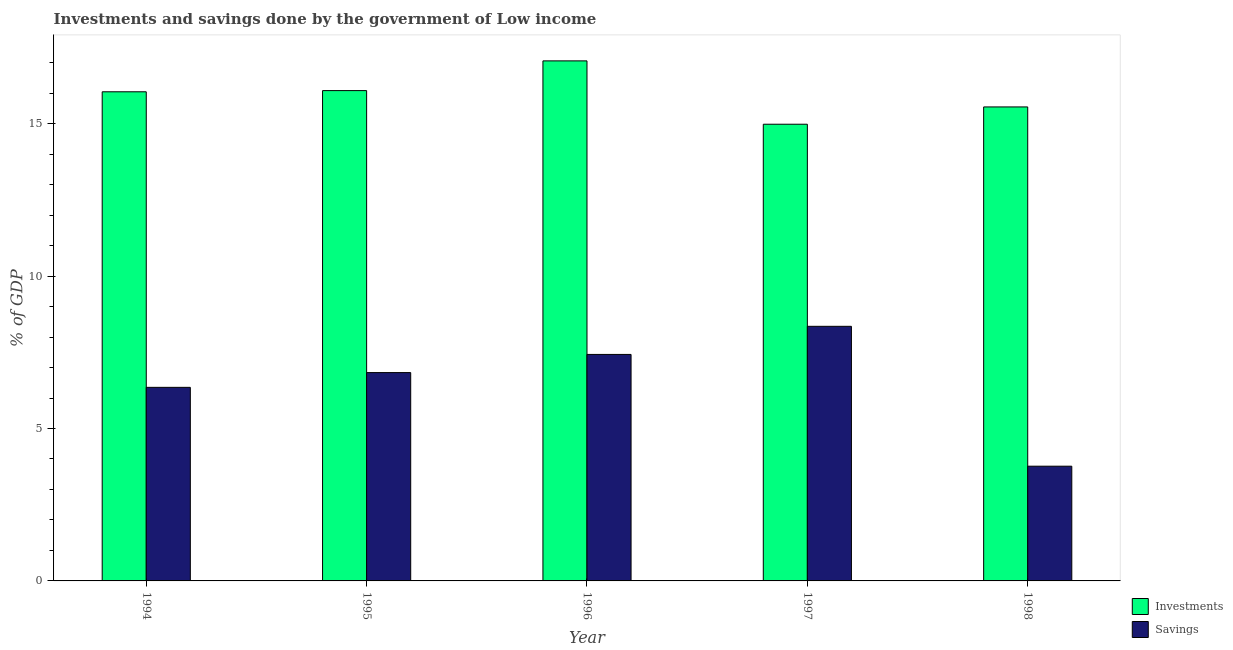How many different coloured bars are there?
Offer a very short reply. 2. How many groups of bars are there?
Offer a terse response. 5. Are the number of bars on each tick of the X-axis equal?
Your response must be concise. Yes. How many bars are there on the 3rd tick from the left?
Provide a succinct answer. 2. What is the label of the 3rd group of bars from the left?
Make the answer very short. 1996. In how many cases, is the number of bars for a given year not equal to the number of legend labels?
Keep it short and to the point. 0. What is the savings of government in 1996?
Ensure brevity in your answer.  7.43. Across all years, what is the maximum savings of government?
Provide a short and direct response. 8.35. Across all years, what is the minimum investments of government?
Your answer should be compact. 14.98. In which year was the savings of government minimum?
Your response must be concise. 1998. What is the total savings of government in the graph?
Make the answer very short. 32.73. What is the difference between the investments of government in 1997 and that in 1998?
Make the answer very short. -0.57. What is the difference between the savings of government in 1995 and the investments of government in 1996?
Provide a short and direct response. -0.6. What is the average investments of government per year?
Your answer should be compact. 15.94. In how many years, is the investments of government greater than 12 %?
Ensure brevity in your answer.  5. What is the ratio of the savings of government in 1994 to that in 1995?
Provide a short and direct response. 0.93. What is the difference between the highest and the second highest investments of government?
Your answer should be very brief. 0.97. What is the difference between the highest and the lowest investments of government?
Make the answer very short. 2.08. In how many years, is the investments of government greater than the average investments of government taken over all years?
Your response must be concise. 3. What does the 2nd bar from the left in 1994 represents?
Your answer should be very brief. Savings. What does the 2nd bar from the right in 1996 represents?
Keep it short and to the point. Investments. How many bars are there?
Provide a short and direct response. 10. Are all the bars in the graph horizontal?
Keep it short and to the point. No. What is the difference between two consecutive major ticks on the Y-axis?
Provide a short and direct response. 5. Does the graph contain any zero values?
Your response must be concise. No. Does the graph contain grids?
Ensure brevity in your answer.  No. How many legend labels are there?
Your answer should be compact. 2. How are the legend labels stacked?
Make the answer very short. Vertical. What is the title of the graph?
Your response must be concise. Investments and savings done by the government of Low income. Does "Commercial service exports" appear as one of the legend labels in the graph?
Give a very brief answer. No. What is the label or title of the X-axis?
Your response must be concise. Year. What is the label or title of the Y-axis?
Give a very brief answer. % of GDP. What is the % of GDP of Investments in 1994?
Make the answer very short. 16.05. What is the % of GDP in Savings in 1994?
Provide a short and direct response. 6.35. What is the % of GDP of Investments in 1995?
Offer a terse response. 16.09. What is the % of GDP in Savings in 1995?
Provide a succinct answer. 6.83. What is the % of GDP in Investments in 1996?
Offer a terse response. 17.06. What is the % of GDP in Savings in 1996?
Keep it short and to the point. 7.43. What is the % of GDP in Investments in 1997?
Provide a short and direct response. 14.98. What is the % of GDP in Savings in 1997?
Ensure brevity in your answer.  8.35. What is the % of GDP of Investments in 1998?
Keep it short and to the point. 15.55. What is the % of GDP in Savings in 1998?
Your answer should be compact. 3.76. Across all years, what is the maximum % of GDP of Investments?
Make the answer very short. 17.06. Across all years, what is the maximum % of GDP in Savings?
Provide a short and direct response. 8.35. Across all years, what is the minimum % of GDP of Investments?
Offer a terse response. 14.98. Across all years, what is the minimum % of GDP in Savings?
Give a very brief answer. 3.76. What is the total % of GDP of Investments in the graph?
Give a very brief answer. 79.72. What is the total % of GDP of Savings in the graph?
Keep it short and to the point. 32.73. What is the difference between the % of GDP of Investments in 1994 and that in 1995?
Provide a succinct answer. -0.04. What is the difference between the % of GDP of Savings in 1994 and that in 1995?
Provide a short and direct response. -0.48. What is the difference between the % of GDP of Investments in 1994 and that in 1996?
Your answer should be compact. -1.01. What is the difference between the % of GDP in Savings in 1994 and that in 1996?
Your response must be concise. -1.08. What is the difference between the % of GDP of Investments in 1994 and that in 1997?
Keep it short and to the point. 1.06. What is the difference between the % of GDP of Savings in 1994 and that in 1997?
Provide a short and direct response. -2. What is the difference between the % of GDP in Investments in 1994 and that in 1998?
Provide a succinct answer. 0.5. What is the difference between the % of GDP of Savings in 1994 and that in 1998?
Provide a succinct answer. 2.59. What is the difference between the % of GDP in Investments in 1995 and that in 1996?
Keep it short and to the point. -0.97. What is the difference between the % of GDP in Savings in 1995 and that in 1996?
Your answer should be compact. -0.6. What is the difference between the % of GDP in Investments in 1995 and that in 1997?
Offer a terse response. 1.1. What is the difference between the % of GDP of Savings in 1995 and that in 1997?
Provide a succinct answer. -1.52. What is the difference between the % of GDP of Investments in 1995 and that in 1998?
Provide a succinct answer. 0.54. What is the difference between the % of GDP in Savings in 1995 and that in 1998?
Provide a succinct answer. 3.07. What is the difference between the % of GDP in Investments in 1996 and that in 1997?
Your answer should be compact. 2.08. What is the difference between the % of GDP in Savings in 1996 and that in 1997?
Make the answer very short. -0.92. What is the difference between the % of GDP in Investments in 1996 and that in 1998?
Make the answer very short. 1.51. What is the difference between the % of GDP of Savings in 1996 and that in 1998?
Give a very brief answer. 3.67. What is the difference between the % of GDP of Investments in 1997 and that in 1998?
Offer a very short reply. -0.57. What is the difference between the % of GDP of Savings in 1997 and that in 1998?
Give a very brief answer. 4.59. What is the difference between the % of GDP in Investments in 1994 and the % of GDP in Savings in 1995?
Offer a terse response. 9.21. What is the difference between the % of GDP in Investments in 1994 and the % of GDP in Savings in 1996?
Ensure brevity in your answer.  8.62. What is the difference between the % of GDP in Investments in 1994 and the % of GDP in Savings in 1997?
Keep it short and to the point. 7.69. What is the difference between the % of GDP of Investments in 1994 and the % of GDP of Savings in 1998?
Offer a very short reply. 12.28. What is the difference between the % of GDP of Investments in 1995 and the % of GDP of Savings in 1996?
Ensure brevity in your answer.  8.66. What is the difference between the % of GDP of Investments in 1995 and the % of GDP of Savings in 1997?
Offer a very short reply. 7.73. What is the difference between the % of GDP of Investments in 1995 and the % of GDP of Savings in 1998?
Ensure brevity in your answer.  12.32. What is the difference between the % of GDP in Investments in 1996 and the % of GDP in Savings in 1997?
Your answer should be compact. 8.71. What is the difference between the % of GDP of Investments in 1996 and the % of GDP of Savings in 1998?
Keep it short and to the point. 13.3. What is the difference between the % of GDP of Investments in 1997 and the % of GDP of Savings in 1998?
Provide a short and direct response. 11.22. What is the average % of GDP in Investments per year?
Your response must be concise. 15.95. What is the average % of GDP in Savings per year?
Your answer should be compact. 6.55. In the year 1994, what is the difference between the % of GDP of Investments and % of GDP of Savings?
Provide a short and direct response. 9.7. In the year 1995, what is the difference between the % of GDP of Investments and % of GDP of Savings?
Keep it short and to the point. 9.25. In the year 1996, what is the difference between the % of GDP of Investments and % of GDP of Savings?
Offer a terse response. 9.63. In the year 1997, what is the difference between the % of GDP in Investments and % of GDP in Savings?
Offer a very short reply. 6.63. In the year 1998, what is the difference between the % of GDP of Investments and % of GDP of Savings?
Make the answer very short. 11.79. What is the ratio of the % of GDP in Investments in 1994 to that in 1995?
Your answer should be very brief. 1. What is the ratio of the % of GDP in Savings in 1994 to that in 1995?
Make the answer very short. 0.93. What is the ratio of the % of GDP in Investments in 1994 to that in 1996?
Offer a terse response. 0.94. What is the ratio of the % of GDP of Savings in 1994 to that in 1996?
Provide a succinct answer. 0.85. What is the ratio of the % of GDP in Investments in 1994 to that in 1997?
Give a very brief answer. 1.07. What is the ratio of the % of GDP in Savings in 1994 to that in 1997?
Make the answer very short. 0.76. What is the ratio of the % of GDP of Investments in 1994 to that in 1998?
Offer a very short reply. 1.03. What is the ratio of the % of GDP of Savings in 1994 to that in 1998?
Give a very brief answer. 1.69. What is the ratio of the % of GDP of Investments in 1995 to that in 1996?
Offer a terse response. 0.94. What is the ratio of the % of GDP in Savings in 1995 to that in 1996?
Keep it short and to the point. 0.92. What is the ratio of the % of GDP in Investments in 1995 to that in 1997?
Ensure brevity in your answer.  1.07. What is the ratio of the % of GDP in Savings in 1995 to that in 1997?
Your answer should be very brief. 0.82. What is the ratio of the % of GDP in Investments in 1995 to that in 1998?
Make the answer very short. 1.03. What is the ratio of the % of GDP in Savings in 1995 to that in 1998?
Provide a succinct answer. 1.82. What is the ratio of the % of GDP of Investments in 1996 to that in 1997?
Your answer should be compact. 1.14. What is the ratio of the % of GDP of Savings in 1996 to that in 1997?
Keep it short and to the point. 0.89. What is the ratio of the % of GDP in Investments in 1996 to that in 1998?
Your answer should be very brief. 1.1. What is the ratio of the % of GDP of Savings in 1996 to that in 1998?
Give a very brief answer. 1.97. What is the ratio of the % of GDP in Investments in 1997 to that in 1998?
Ensure brevity in your answer.  0.96. What is the ratio of the % of GDP of Savings in 1997 to that in 1998?
Your answer should be very brief. 2.22. What is the difference between the highest and the second highest % of GDP of Savings?
Provide a succinct answer. 0.92. What is the difference between the highest and the lowest % of GDP in Investments?
Provide a succinct answer. 2.08. What is the difference between the highest and the lowest % of GDP in Savings?
Give a very brief answer. 4.59. 